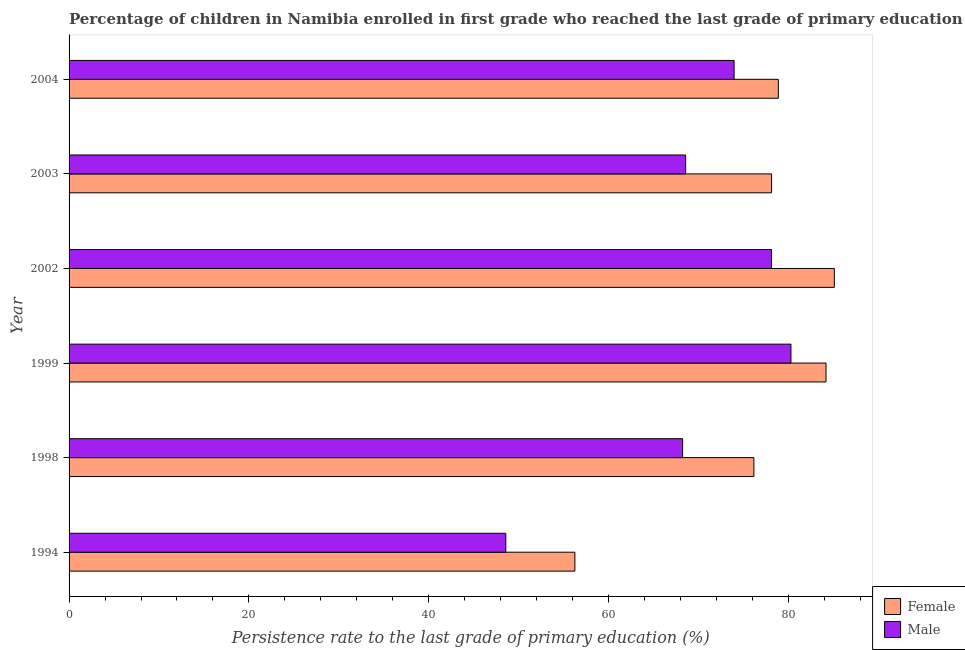How many groups of bars are there?
Your response must be concise. 6. Are the number of bars per tick equal to the number of legend labels?
Your answer should be compact. Yes. How many bars are there on the 4th tick from the bottom?
Your response must be concise. 2. In how many cases, is the number of bars for a given year not equal to the number of legend labels?
Ensure brevity in your answer.  0. What is the persistence rate of male students in 1999?
Offer a very short reply. 80.27. Across all years, what is the maximum persistence rate of male students?
Ensure brevity in your answer.  80.27. Across all years, what is the minimum persistence rate of female students?
Your answer should be compact. 56.24. In which year was the persistence rate of female students maximum?
Provide a succinct answer. 2002. In which year was the persistence rate of female students minimum?
Provide a short and direct response. 1994. What is the total persistence rate of female students in the graph?
Make the answer very short. 458.64. What is the difference between the persistence rate of male students in 2002 and that in 2003?
Make the answer very short. 9.55. What is the difference between the persistence rate of female students in 2003 and the persistence rate of male students in 1994?
Ensure brevity in your answer.  29.55. What is the average persistence rate of male students per year?
Make the answer very short. 69.61. In the year 1999, what is the difference between the persistence rate of male students and persistence rate of female students?
Provide a succinct answer. -3.9. What is the ratio of the persistence rate of male students in 2002 to that in 2003?
Your answer should be compact. 1.14. Is the difference between the persistence rate of female students in 2003 and 2004 greater than the difference between the persistence rate of male students in 2003 and 2004?
Make the answer very short. Yes. What is the difference between the highest and the second highest persistence rate of male students?
Your response must be concise. 2.16. What is the difference between the highest and the lowest persistence rate of female students?
Your response must be concise. 28.85. Is the sum of the persistence rate of male students in 1999 and 2004 greater than the maximum persistence rate of female students across all years?
Give a very brief answer. Yes. What does the 1st bar from the top in 1994 represents?
Keep it short and to the point. Male. What does the 1st bar from the bottom in 2002 represents?
Make the answer very short. Female. How many bars are there?
Your answer should be very brief. 12. Does the graph contain any zero values?
Your response must be concise. No. Where does the legend appear in the graph?
Your answer should be very brief. Bottom right. What is the title of the graph?
Ensure brevity in your answer.  Percentage of children in Namibia enrolled in first grade who reached the last grade of primary education. What is the label or title of the X-axis?
Make the answer very short. Persistence rate to the last grade of primary education (%). What is the label or title of the Y-axis?
Keep it short and to the point. Year. What is the Persistence rate to the last grade of primary education (%) of Female in 1994?
Provide a short and direct response. 56.24. What is the Persistence rate to the last grade of primary education (%) in Male in 1994?
Make the answer very short. 48.56. What is the Persistence rate to the last grade of primary education (%) in Female in 1998?
Give a very brief answer. 76.15. What is the Persistence rate to the last grade of primary education (%) in Male in 1998?
Give a very brief answer. 68.23. What is the Persistence rate to the last grade of primary education (%) in Female in 1999?
Provide a short and direct response. 84.17. What is the Persistence rate to the last grade of primary education (%) in Male in 1999?
Provide a short and direct response. 80.27. What is the Persistence rate to the last grade of primary education (%) of Female in 2002?
Make the answer very short. 85.09. What is the Persistence rate to the last grade of primary education (%) in Male in 2002?
Keep it short and to the point. 78.11. What is the Persistence rate to the last grade of primary education (%) in Female in 2003?
Provide a succinct answer. 78.12. What is the Persistence rate to the last grade of primary education (%) in Male in 2003?
Provide a succinct answer. 68.56. What is the Persistence rate to the last grade of primary education (%) of Female in 2004?
Keep it short and to the point. 78.87. What is the Persistence rate to the last grade of primary education (%) in Male in 2004?
Provide a short and direct response. 73.95. Across all years, what is the maximum Persistence rate to the last grade of primary education (%) of Female?
Ensure brevity in your answer.  85.09. Across all years, what is the maximum Persistence rate to the last grade of primary education (%) of Male?
Give a very brief answer. 80.27. Across all years, what is the minimum Persistence rate to the last grade of primary education (%) of Female?
Keep it short and to the point. 56.24. Across all years, what is the minimum Persistence rate to the last grade of primary education (%) of Male?
Provide a short and direct response. 48.56. What is the total Persistence rate to the last grade of primary education (%) of Female in the graph?
Provide a short and direct response. 458.64. What is the total Persistence rate to the last grade of primary education (%) in Male in the graph?
Offer a terse response. 417.68. What is the difference between the Persistence rate to the last grade of primary education (%) in Female in 1994 and that in 1998?
Make the answer very short. -19.9. What is the difference between the Persistence rate to the last grade of primary education (%) of Male in 1994 and that in 1998?
Keep it short and to the point. -19.66. What is the difference between the Persistence rate to the last grade of primary education (%) in Female in 1994 and that in 1999?
Your answer should be very brief. -27.93. What is the difference between the Persistence rate to the last grade of primary education (%) of Male in 1994 and that in 1999?
Offer a very short reply. -31.71. What is the difference between the Persistence rate to the last grade of primary education (%) in Female in 1994 and that in 2002?
Keep it short and to the point. -28.85. What is the difference between the Persistence rate to the last grade of primary education (%) of Male in 1994 and that in 2002?
Keep it short and to the point. -29.55. What is the difference between the Persistence rate to the last grade of primary education (%) of Female in 1994 and that in 2003?
Ensure brevity in your answer.  -21.87. What is the difference between the Persistence rate to the last grade of primary education (%) of Male in 1994 and that in 2003?
Offer a very short reply. -20. What is the difference between the Persistence rate to the last grade of primary education (%) of Female in 1994 and that in 2004?
Provide a succinct answer. -22.62. What is the difference between the Persistence rate to the last grade of primary education (%) in Male in 1994 and that in 2004?
Your answer should be very brief. -25.39. What is the difference between the Persistence rate to the last grade of primary education (%) of Female in 1998 and that in 1999?
Give a very brief answer. -8.02. What is the difference between the Persistence rate to the last grade of primary education (%) in Male in 1998 and that in 1999?
Your answer should be very brief. -12.05. What is the difference between the Persistence rate to the last grade of primary education (%) in Female in 1998 and that in 2002?
Ensure brevity in your answer.  -8.95. What is the difference between the Persistence rate to the last grade of primary education (%) in Male in 1998 and that in 2002?
Make the answer very short. -9.88. What is the difference between the Persistence rate to the last grade of primary education (%) in Female in 1998 and that in 2003?
Offer a terse response. -1.97. What is the difference between the Persistence rate to the last grade of primary education (%) in Male in 1998 and that in 2003?
Give a very brief answer. -0.33. What is the difference between the Persistence rate to the last grade of primary education (%) of Female in 1998 and that in 2004?
Provide a short and direct response. -2.72. What is the difference between the Persistence rate to the last grade of primary education (%) in Male in 1998 and that in 2004?
Make the answer very short. -5.72. What is the difference between the Persistence rate to the last grade of primary education (%) of Female in 1999 and that in 2002?
Provide a succinct answer. -0.92. What is the difference between the Persistence rate to the last grade of primary education (%) of Male in 1999 and that in 2002?
Provide a succinct answer. 2.16. What is the difference between the Persistence rate to the last grade of primary education (%) of Female in 1999 and that in 2003?
Provide a succinct answer. 6.05. What is the difference between the Persistence rate to the last grade of primary education (%) of Male in 1999 and that in 2003?
Ensure brevity in your answer.  11.71. What is the difference between the Persistence rate to the last grade of primary education (%) in Female in 1999 and that in 2004?
Your response must be concise. 5.3. What is the difference between the Persistence rate to the last grade of primary education (%) in Male in 1999 and that in 2004?
Offer a very short reply. 6.32. What is the difference between the Persistence rate to the last grade of primary education (%) of Female in 2002 and that in 2003?
Offer a very short reply. 6.98. What is the difference between the Persistence rate to the last grade of primary education (%) in Male in 2002 and that in 2003?
Offer a terse response. 9.55. What is the difference between the Persistence rate to the last grade of primary education (%) in Female in 2002 and that in 2004?
Give a very brief answer. 6.22. What is the difference between the Persistence rate to the last grade of primary education (%) in Male in 2002 and that in 2004?
Your answer should be compact. 4.16. What is the difference between the Persistence rate to the last grade of primary education (%) in Female in 2003 and that in 2004?
Offer a very short reply. -0.75. What is the difference between the Persistence rate to the last grade of primary education (%) of Male in 2003 and that in 2004?
Offer a terse response. -5.39. What is the difference between the Persistence rate to the last grade of primary education (%) of Female in 1994 and the Persistence rate to the last grade of primary education (%) of Male in 1998?
Keep it short and to the point. -11.98. What is the difference between the Persistence rate to the last grade of primary education (%) in Female in 1994 and the Persistence rate to the last grade of primary education (%) in Male in 1999?
Your answer should be compact. -24.03. What is the difference between the Persistence rate to the last grade of primary education (%) of Female in 1994 and the Persistence rate to the last grade of primary education (%) of Male in 2002?
Ensure brevity in your answer.  -21.86. What is the difference between the Persistence rate to the last grade of primary education (%) in Female in 1994 and the Persistence rate to the last grade of primary education (%) in Male in 2003?
Offer a very short reply. -12.31. What is the difference between the Persistence rate to the last grade of primary education (%) in Female in 1994 and the Persistence rate to the last grade of primary education (%) in Male in 2004?
Your answer should be compact. -17.7. What is the difference between the Persistence rate to the last grade of primary education (%) of Female in 1998 and the Persistence rate to the last grade of primary education (%) of Male in 1999?
Your answer should be compact. -4.12. What is the difference between the Persistence rate to the last grade of primary education (%) in Female in 1998 and the Persistence rate to the last grade of primary education (%) in Male in 2002?
Offer a very short reply. -1.96. What is the difference between the Persistence rate to the last grade of primary education (%) of Female in 1998 and the Persistence rate to the last grade of primary education (%) of Male in 2003?
Make the answer very short. 7.59. What is the difference between the Persistence rate to the last grade of primary education (%) of Female in 1998 and the Persistence rate to the last grade of primary education (%) of Male in 2004?
Keep it short and to the point. 2.2. What is the difference between the Persistence rate to the last grade of primary education (%) of Female in 1999 and the Persistence rate to the last grade of primary education (%) of Male in 2002?
Provide a short and direct response. 6.06. What is the difference between the Persistence rate to the last grade of primary education (%) in Female in 1999 and the Persistence rate to the last grade of primary education (%) in Male in 2003?
Offer a terse response. 15.61. What is the difference between the Persistence rate to the last grade of primary education (%) in Female in 1999 and the Persistence rate to the last grade of primary education (%) in Male in 2004?
Your answer should be very brief. 10.22. What is the difference between the Persistence rate to the last grade of primary education (%) of Female in 2002 and the Persistence rate to the last grade of primary education (%) of Male in 2003?
Keep it short and to the point. 16.53. What is the difference between the Persistence rate to the last grade of primary education (%) of Female in 2002 and the Persistence rate to the last grade of primary education (%) of Male in 2004?
Provide a short and direct response. 11.14. What is the difference between the Persistence rate to the last grade of primary education (%) of Female in 2003 and the Persistence rate to the last grade of primary education (%) of Male in 2004?
Your answer should be compact. 4.17. What is the average Persistence rate to the last grade of primary education (%) of Female per year?
Your answer should be very brief. 76.44. What is the average Persistence rate to the last grade of primary education (%) of Male per year?
Provide a succinct answer. 69.61. In the year 1994, what is the difference between the Persistence rate to the last grade of primary education (%) of Female and Persistence rate to the last grade of primary education (%) of Male?
Provide a short and direct response. 7.68. In the year 1998, what is the difference between the Persistence rate to the last grade of primary education (%) in Female and Persistence rate to the last grade of primary education (%) in Male?
Provide a succinct answer. 7.92. In the year 1999, what is the difference between the Persistence rate to the last grade of primary education (%) in Female and Persistence rate to the last grade of primary education (%) in Male?
Offer a terse response. 3.9. In the year 2002, what is the difference between the Persistence rate to the last grade of primary education (%) in Female and Persistence rate to the last grade of primary education (%) in Male?
Your answer should be very brief. 6.99. In the year 2003, what is the difference between the Persistence rate to the last grade of primary education (%) in Female and Persistence rate to the last grade of primary education (%) in Male?
Provide a short and direct response. 9.56. In the year 2004, what is the difference between the Persistence rate to the last grade of primary education (%) in Female and Persistence rate to the last grade of primary education (%) in Male?
Give a very brief answer. 4.92. What is the ratio of the Persistence rate to the last grade of primary education (%) in Female in 1994 to that in 1998?
Provide a succinct answer. 0.74. What is the ratio of the Persistence rate to the last grade of primary education (%) in Male in 1994 to that in 1998?
Your answer should be compact. 0.71. What is the ratio of the Persistence rate to the last grade of primary education (%) of Female in 1994 to that in 1999?
Give a very brief answer. 0.67. What is the ratio of the Persistence rate to the last grade of primary education (%) in Male in 1994 to that in 1999?
Provide a short and direct response. 0.6. What is the ratio of the Persistence rate to the last grade of primary education (%) of Female in 1994 to that in 2002?
Offer a terse response. 0.66. What is the ratio of the Persistence rate to the last grade of primary education (%) of Male in 1994 to that in 2002?
Provide a short and direct response. 0.62. What is the ratio of the Persistence rate to the last grade of primary education (%) in Female in 1994 to that in 2003?
Provide a short and direct response. 0.72. What is the ratio of the Persistence rate to the last grade of primary education (%) of Male in 1994 to that in 2003?
Your answer should be compact. 0.71. What is the ratio of the Persistence rate to the last grade of primary education (%) in Female in 1994 to that in 2004?
Offer a terse response. 0.71. What is the ratio of the Persistence rate to the last grade of primary education (%) in Male in 1994 to that in 2004?
Your response must be concise. 0.66. What is the ratio of the Persistence rate to the last grade of primary education (%) in Female in 1998 to that in 1999?
Your response must be concise. 0.9. What is the ratio of the Persistence rate to the last grade of primary education (%) of Male in 1998 to that in 1999?
Give a very brief answer. 0.85. What is the ratio of the Persistence rate to the last grade of primary education (%) in Female in 1998 to that in 2002?
Offer a terse response. 0.89. What is the ratio of the Persistence rate to the last grade of primary education (%) of Male in 1998 to that in 2002?
Ensure brevity in your answer.  0.87. What is the ratio of the Persistence rate to the last grade of primary education (%) of Female in 1998 to that in 2003?
Offer a very short reply. 0.97. What is the ratio of the Persistence rate to the last grade of primary education (%) in Female in 1998 to that in 2004?
Ensure brevity in your answer.  0.97. What is the ratio of the Persistence rate to the last grade of primary education (%) of Male in 1998 to that in 2004?
Give a very brief answer. 0.92. What is the ratio of the Persistence rate to the last grade of primary education (%) of Male in 1999 to that in 2002?
Your answer should be very brief. 1.03. What is the ratio of the Persistence rate to the last grade of primary education (%) of Female in 1999 to that in 2003?
Your answer should be compact. 1.08. What is the ratio of the Persistence rate to the last grade of primary education (%) in Male in 1999 to that in 2003?
Your response must be concise. 1.17. What is the ratio of the Persistence rate to the last grade of primary education (%) of Female in 1999 to that in 2004?
Provide a succinct answer. 1.07. What is the ratio of the Persistence rate to the last grade of primary education (%) in Male in 1999 to that in 2004?
Offer a very short reply. 1.09. What is the ratio of the Persistence rate to the last grade of primary education (%) of Female in 2002 to that in 2003?
Offer a terse response. 1.09. What is the ratio of the Persistence rate to the last grade of primary education (%) of Male in 2002 to that in 2003?
Your answer should be very brief. 1.14. What is the ratio of the Persistence rate to the last grade of primary education (%) in Female in 2002 to that in 2004?
Offer a very short reply. 1.08. What is the ratio of the Persistence rate to the last grade of primary education (%) of Male in 2002 to that in 2004?
Provide a short and direct response. 1.06. What is the ratio of the Persistence rate to the last grade of primary education (%) in Female in 2003 to that in 2004?
Keep it short and to the point. 0.99. What is the ratio of the Persistence rate to the last grade of primary education (%) of Male in 2003 to that in 2004?
Ensure brevity in your answer.  0.93. What is the difference between the highest and the second highest Persistence rate to the last grade of primary education (%) in Female?
Provide a short and direct response. 0.92. What is the difference between the highest and the second highest Persistence rate to the last grade of primary education (%) of Male?
Provide a succinct answer. 2.16. What is the difference between the highest and the lowest Persistence rate to the last grade of primary education (%) of Female?
Provide a short and direct response. 28.85. What is the difference between the highest and the lowest Persistence rate to the last grade of primary education (%) of Male?
Keep it short and to the point. 31.71. 